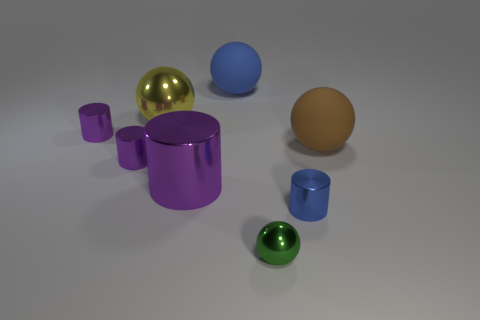Subtract all blue cylinders. How many cylinders are left? 3 Subtract all big metallic cylinders. How many cylinders are left? 3 Add 2 small blue metal things. How many objects exist? 10 Subtract all gray blocks. How many purple spheres are left? 0 Subtract 0 red blocks. How many objects are left? 8 Subtract all brown cylinders. Subtract all cyan spheres. How many cylinders are left? 4 Subtract all metal objects. Subtract all yellow metal balls. How many objects are left? 1 Add 2 yellow metallic spheres. How many yellow metallic spheres are left? 3 Add 4 big blue shiny cylinders. How many big blue shiny cylinders exist? 4 